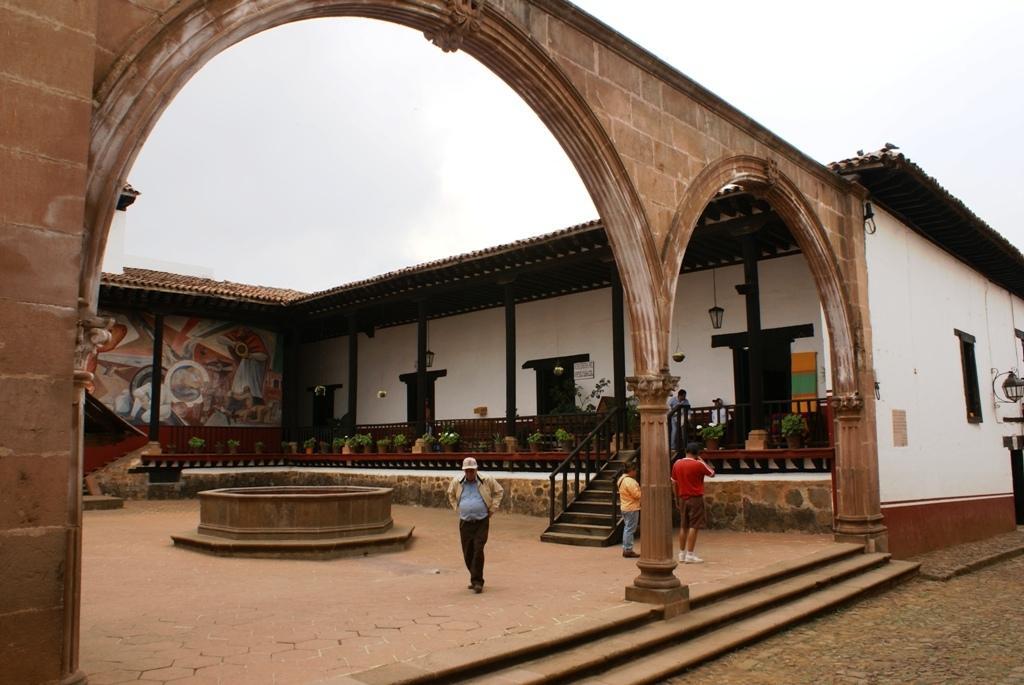In one or two sentences, can you explain what this image depicts? In this image we can see a building with roof, doors and some lights. In the center of the image we can see group of plants in pots, staircase, railings and a group of persons standing on the ground. In the foreground we can see some steps. On the left side of the image we can see a cement tank on the ground. At the top of the image we can see the sky. 